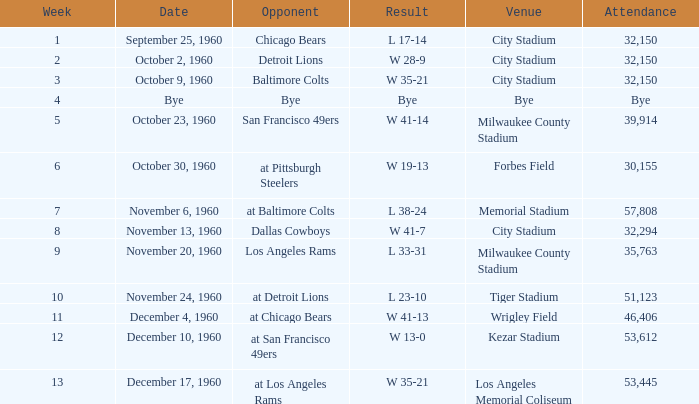How many individuals attended the tiger stadium? L 23-10. Help me parse the entirety of this table. {'header': ['Week', 'Date', 'Opponent', 'Result', 'Venue', 'Attendance'], 'rows': [['1', 'September 25, 1960', 'Chicago Bears', 'L 17-14', 'City Stadium', '32,150'], ['2', 'October 2, 1960', 'Detroit Lions', 'W 28-9', 'City Stadium', '32,150'], ['3', 'October 9, 1960', 'Baltimore Colts', 'W 35-21', 'City Stadium', '32,150'], ['4', 'Bye', 'Bye', 'Bye', 'Bye', 'Bye'], ['5', 'October 23, 1960', 'San Francisco 49ers', 'W 41-14', 'Milwaukee County Stadium', '39,914'], ['6', 'October 30, 1960', 'at Pittsburgh Steelers', 'W 19-13', 'Forbes Field', '30,155'], ['7', 'November 6, 1960', 'at Baltimore Colts', 'L 38-24', 'Memorial Stadium', '57,808'], ['8', 'November 13, 1960', 'Dallas Cowboys', 'W 41-7', 'City Stadium', '32,294'], ['9', 'November 20, 1960', 'Los Angeles Rams', 'L 33-31', 'Milwaukee County Stadium', '35,763'], ['10', 'November 24, 1960', 'at Detroit Lions', 'L 23-10', 'Tiger Stadium', '51,123'], ['11', 'December 4, 1960', 'at Chicago Bears', 'W 41-13', 'Wrigley Field', '46,406'], ['12', 'December 10, 1960', 'at San Francisco 49ers', 'W 13-0', 'Kezar Stadium', '53,612'], ['13', 'December 17, 1960', 'at Los Angeles Rams', 'W 35-21', 'Los Angeles Memorial Coliseum', '53,445']]} 